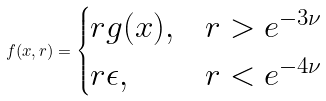Convert formula to latex. <formula><loc_0><loc_0><loc_500><loc_500>f ( x , r ) = \begin{cases} r g ( x ) , & r > e ^ { - 3 \nu } \\ r \epsilon , & r < e ^ { - 4 \nu } \end{cases}</formula> 